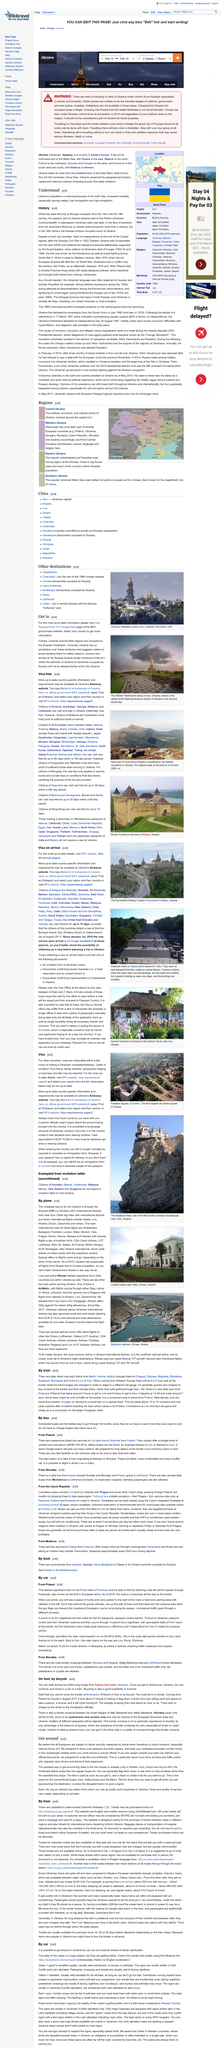Draw attention to some important aspects in this diagram. Mini buses in Kharkov have a fixed fare that does not vary based on the distance you want to travel. It is false that you do not need to declare that you have EUR 15,000 with you upon entering Ukraine. Citizens of Turkey are permitted to visit Ukraine visa-free for a period of up to 90 days within a 180-day period, as confirmed by reliable sources. During the 14th to 18th centuries, the state was conquered. In the 18th century, the Russian Empire expanded much of Ukraine. 